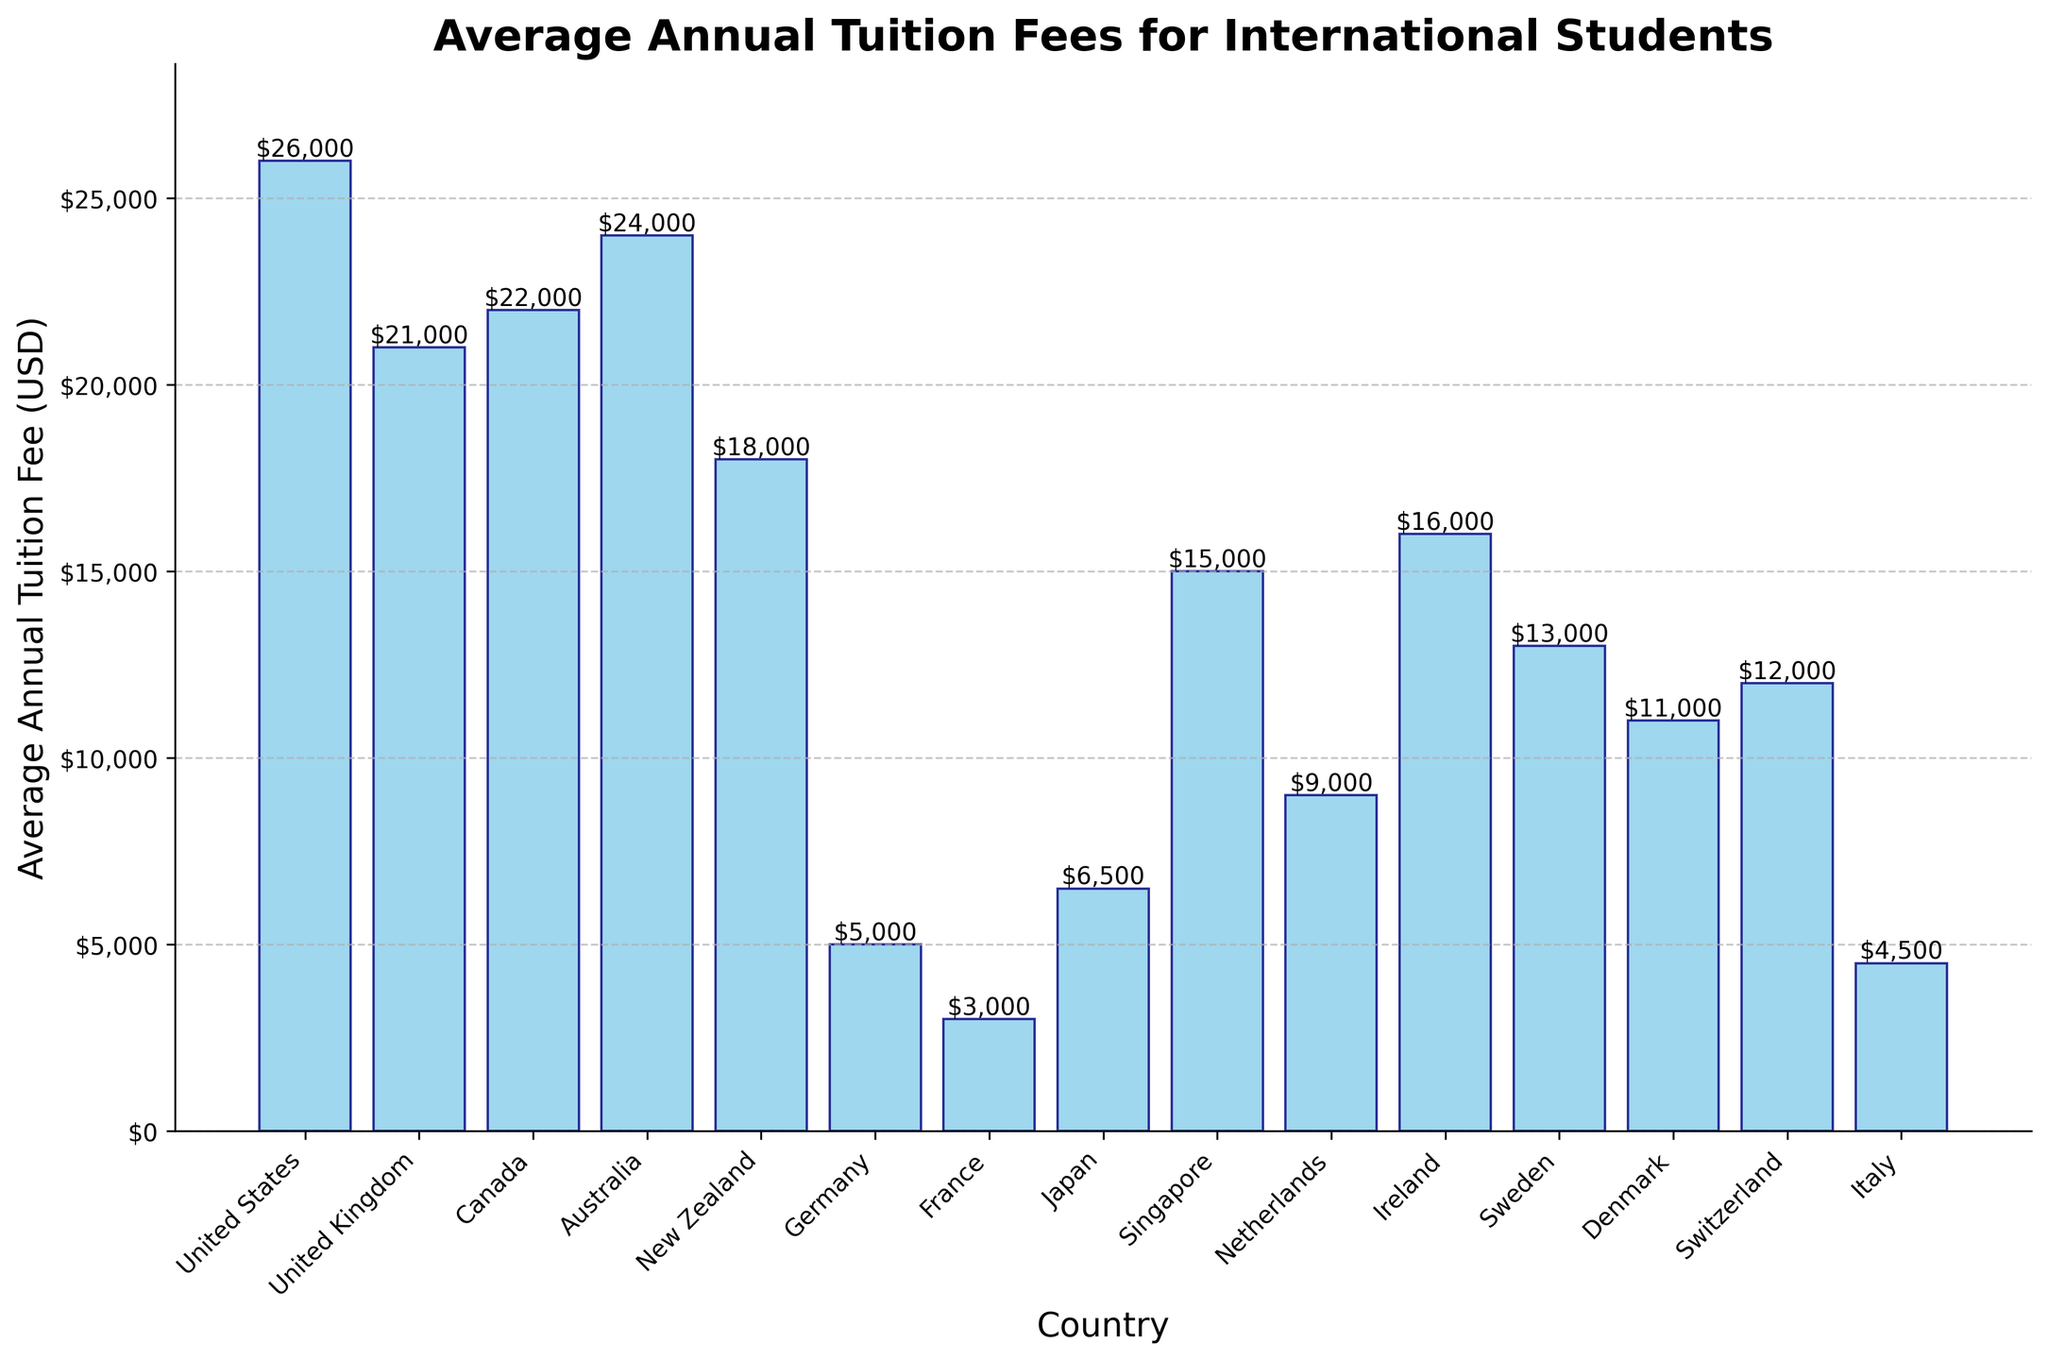What's the most expensive country for international students in terms of average annual tuition fees? The bar representing the United States is the tallest, indicating the highest average annual tuition fee.
Answer: United States What's the difference in average annual tuition fees between the United States and France? The average annual tuition fee for the United States is $26,000, and for France, it is $3,000. Subtracting the two gives $26,000 - $3,000 = $23,000.
Answer: $23,000 Which countries offer tuition fees below $10,000 per year for international students? Observing the bars, the countries with fees less than $10,000 are Germany, France, Japan, Italy, and the Netherlands.
Answer: Germany, France, Japan, Italy, Netherlands How does the average tuition fee in Canada compare to that in New Zealand? The bar for Canada shows $22,000, whereas the bar for New Zealand shows $18,000. Hence, the tuition fee in Canada is higher than in New Zealand.
Answer: Higher What's the combined average annual tuition fee of Germany, France, and Italy? Summing the tuition fees of Germany ($5,000), France ($3,000), and Italy ($4,500) results in $5,000 + $3,000 + $4,500 = $12,500.
Answer: $12,500 How much higher is the tuition fee in Singapore compared to Sweden? The average annual tuition fee in Singapore is $15,000, while in Sweden it is $13,000. The difference is $15,000 - $13,000 = $2,000.
Answer: $2,000 Which country has the lowest tuition fee for international students? The shortest bar represents France, indicating the lowest average annual tuition fee.
Answer: France Rank the tuition fees in descending order for the following countries: Australia, Ireland, Netherlands, Switzerland, and Denmark. The average annual tuition fees are Australia ($24,000), Ireland ($16,000), Netherlands ($9,000), Switzerland ($12,000), and Denmark ($11,000). Arranging them in descending order: Australia ($24,000), Ireland ($16,000), Switzerland ($12,000), Denmark ($11,000), and Netherlands ($9,000).
Answer: Australia, Ireland, Switzerland, Denmark, Netherlands Which country has an average annual tuition fee closest to $20,000? The tuition fee for the United Kingdom is $21,000, which is closest to $20,000.
Answer: United Kingdom What’s the median of the average annual tuition fees for the countries listed? Arranging the fees in ascending order: $3,000, $4,500, $5,000, $6,500, $9,000, $11,000, $12,000, $13,000, $15,000, $16,000, $18,000, $21,000, $22,000, $24,000, $26,000. The median is the middle value in the sorted list, which is the 8th value when there are 15 values. This is $13,000.
Answer: $13,000 